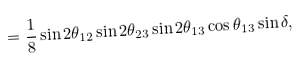Convert formula to latex. <formula><loc_0><loc_0><loc_500><loc_500>= \frac { 1 } { 8 } \sin 2 \theta _ { 1 2 } \sin 2 \theta _ { 2 3 } \sin 2 \theta _ { 1 3 } \cos \theta _ { 1 3 } \sin \delta ,</formula> 